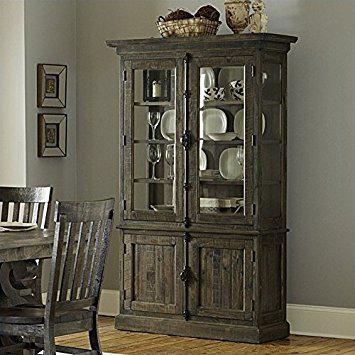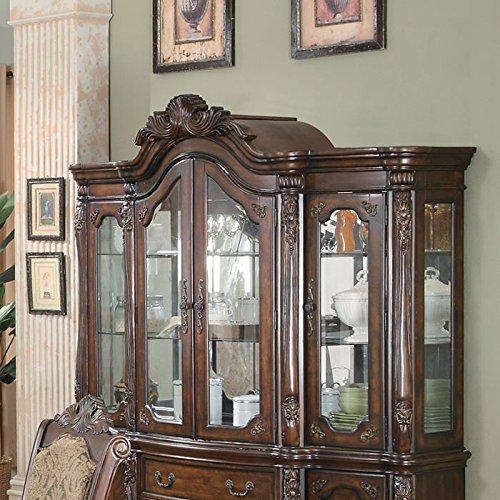The first image is the image on the left, the second image is the image on the right. Assess this claim about the two images: "There is a combined total of three chairs between the two images.". Correct or not? Answer yes or no. Yes. The first image is the image on the left, the second image is the image on the right. For the images displayed, is the sentence "There is basket of dark objects atop the china cabinet in the image on the right." factually correct? Answer yes or no. No. 